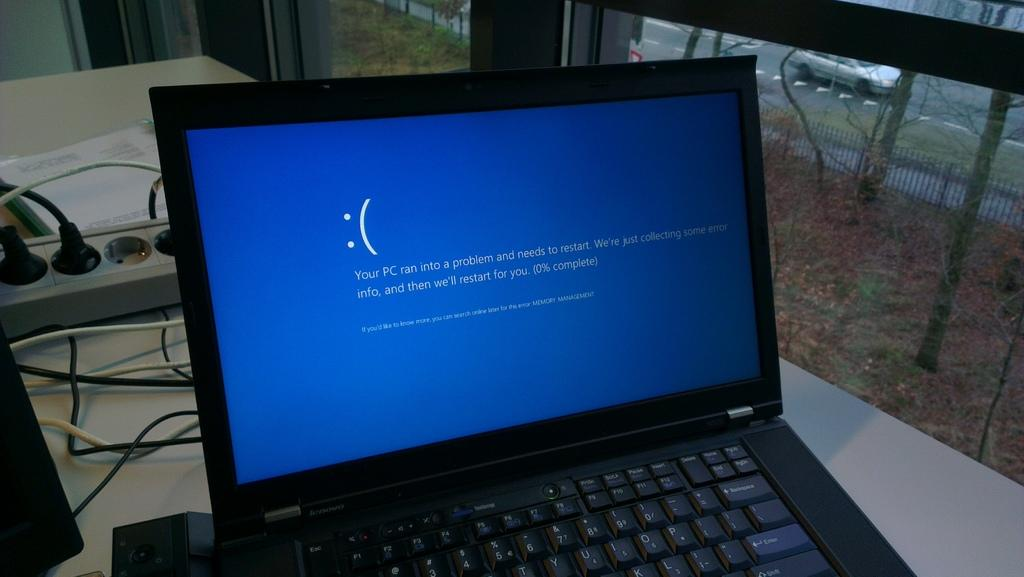<image>
Share a concise interpretation of the image provided. Someone's computer ran into a problem and needs to restart. 